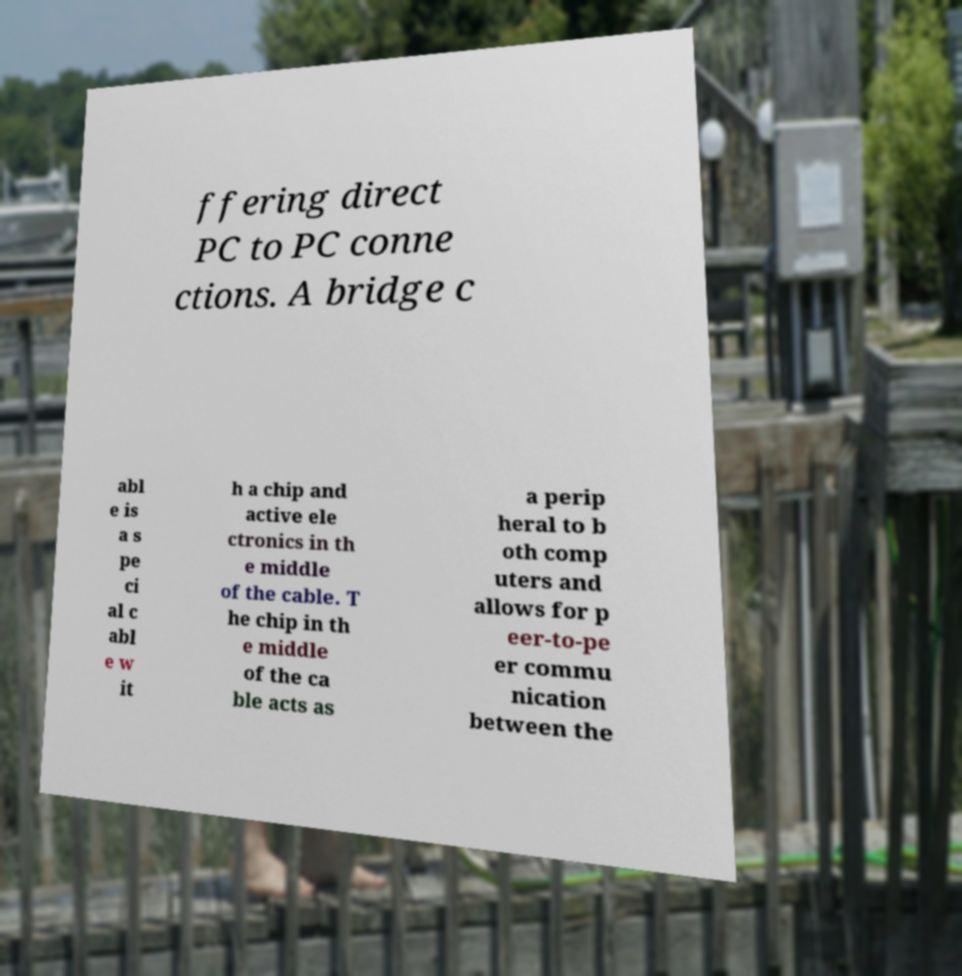Please identify and transcribe the text found in this image. ffering direct PC to PC conne ctions. A bridge c abl e is a s pe ci al c abl e w it h a chip and active ele ctronics in th e middle of the cable. T he chip in th e middle of the ca ble acts as a perip heral to b oth comp uters and allows for p eer-to-pe er commu nication between the 